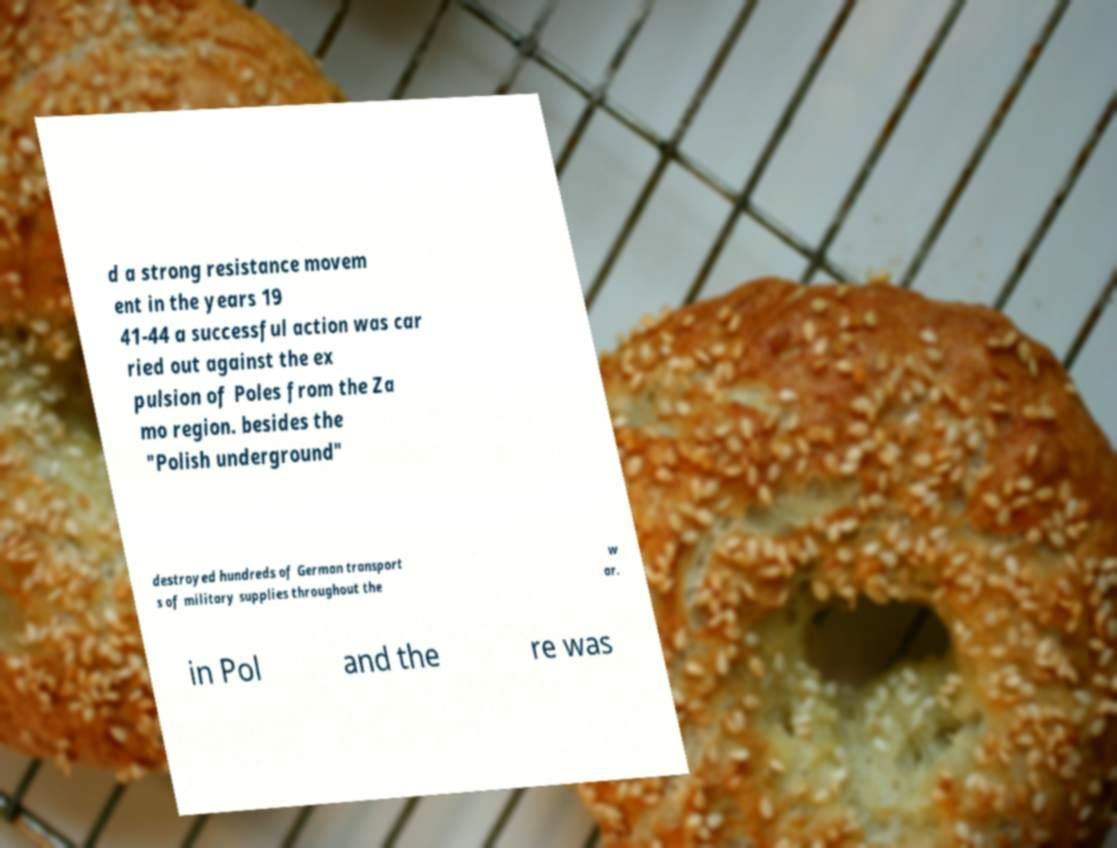What messages or text are displayed in this image? I need them in a readable, typed format. d a strong resistance movem ent in the years 19 41-44 a successful action was car ried out against the ex pulsion of Poles from the Za mo region. besides the "Polish underground" destroyed hundreds of German transport s of military supplies throughout the w ar. in Pol and the re was 